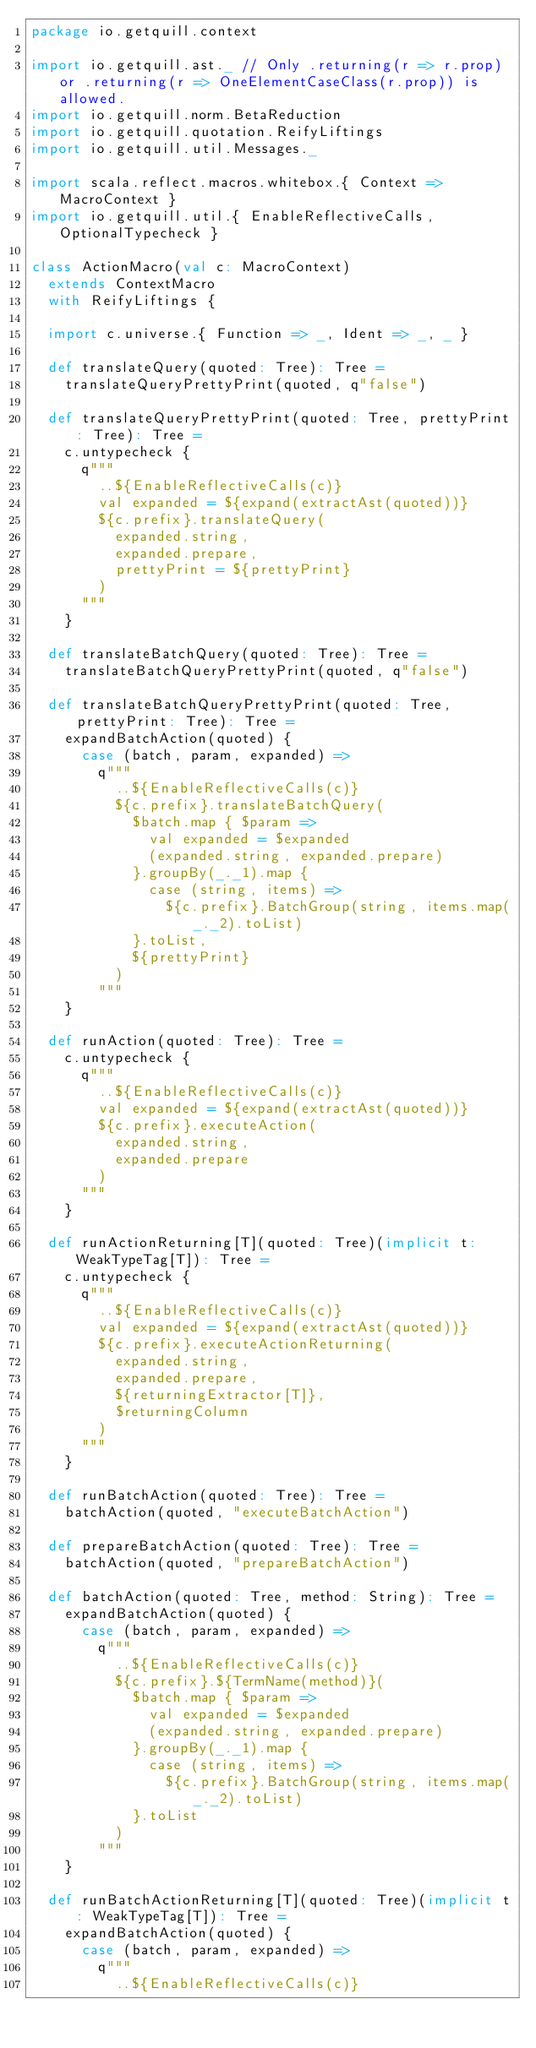<code> <loc_0><loc_0><loc_500><loc_500><_Scala_>package io.getquill.context

import io.getquill.ast._ // Only .returning(r => r.prop) or .returning(r => OneElementCaseClass(r.prop)) is allowed.
import io.getquill.norm.BetaReduction
import io.getquill.quotation.ReifyLiftings
import io.getquill.util.Messages._

import scala.reflect.macros.whitebox.{ Context => MacroContext }
import io.getquill.util.{ EnableReflectiveCalls, OptionalTypecheck }

class ActionMacro(val c: MacroContext)
  extends ContextMacro
  with ReifyLiftings {

  import c.universe.{ Function => _, Ident => _, _ }

  def translateQuery(quoted: Tree): Tree =
    translateQueryPrettyPrint(quoted, q"false")

  def translateQueryPrettyPrint(quoted: Tree, prettyPrint: Tree): Tree =
    c.untypecheck {
      q"""
        ..${EnableReflectiveCalls(c)}
        val expanded = ${expand(extractAst(quoted))}
        ${c.prefix}.translateQuery(
          expanded.string,
          expanded.prepare,
          prettyPrint = ${prettyPrint}
        )
      """
    }

  def translateBatchQuery(quoted: Tree): Tree =
    translateBatchQueryPrettyPrint(quoted, q"false")

  def translateBatchQueryPrettyPrint(quoted: Tree, prettyPrint: Tree): Tree =
    expandBatchAction(quoted) {
      case (batch, param, expanded) =>
        q"""
          ..${EnableReflectiveCalls(c)}
          ${c.prefix}.translateBatchQuery(
            $batch.map { $param =>
              val expanded = $expanded
              (expanded.string, expanded.prepare)
            }.groupBy(_._1).map {
              case (string, items) =>
                ${c.prefix}.BatchGroup(string, items.map(_._2).toList)
            }.toList,
            ${prettyPrint}
          )
        """
    }

  def runAction(quoted: Tree): Tree =
    c.untypecheck {
      q"""
        ..${EnableReflectiveCalls(c)}
        val expanded = ${expand(extractAst(quoted))}
        ${c.prefix}.executeAction(
          expanded.string,
          expanded.prepare
        )
      """
    }

  def runActionReturning[T](quoted: Tree)(implicit t: WeakTypeTag[T]): Tree =
    c.untypecheck {
      q"""
        ..${EnableReflectiveCalls(c)}
        val expanded = ${expand(extractAst(quoted))}
        ${c.prefix}.executeActionReturning(
          expanded.string,
          expanded.prepare,
          ${returningExtractor[T]},
          $returningColumn
        )
      """
    }

  def runBatchAction(quoted: Tree): Tree =
    batchAction(quoted, "executeBatchAction")

  def prepareBatchAction(quoted: Tree): Tree =
    batchAction(quoted, "prepareBatchAction")

  def batchAction(quoted: Tree, method: String): Tree =
    expandBatchAction(quoted) {
      case (batch, param, expanded) =>
        q"""
          ..${EnableReflectiveCalls(c)}
          ${c.prefix}.${TermName(method)}(
            $batch.map { $param =>
              val expanded = $expanded
              (expanded.string, expanded.prepare)
            }.groupBy(_._1).map {
              case (string, items) =>
                ${c.prefix}.BatchGroup(string, items.map(_._2).toList)
            }.toList
          )
        """
    }

  def runBatchActionReturning[T](quoted: Tree)(implicit t: WeakTypeTag[T]): Tree =
    expandBatchAction(quoted) {
      case (batch, param, expanded) =>
        q"""
          ..${EnableReflectiveCalls(c)}</code> 